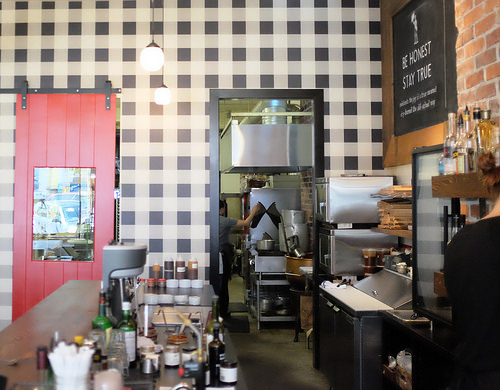<image>
Is the wall behind the floor? No. The wall is not behind the floor. From this viewpoint, the wall appears to be positioned elsewhere in the scene. Is there a pan behind the pot? No. The pan is not behind the pot. From this viewpoint, the pan appears to be positioned elsewhere in the scene. 